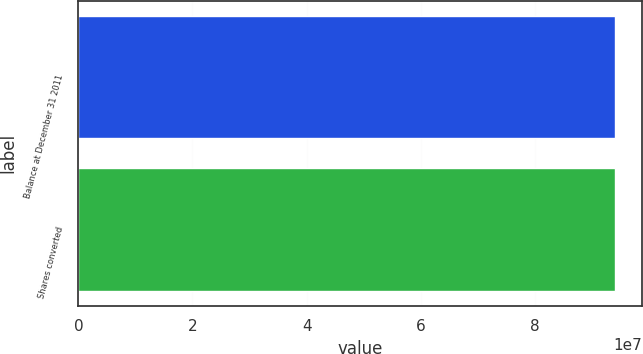Convert chart. <chart><loc_0><loc_0><loc_500><loc_500><bar_chart><fcel>Balance at December 31 2011<fcel>Shares converted<nl><fcel>9.41326e+07<fcel>9.41326e+07<nl></chart> 